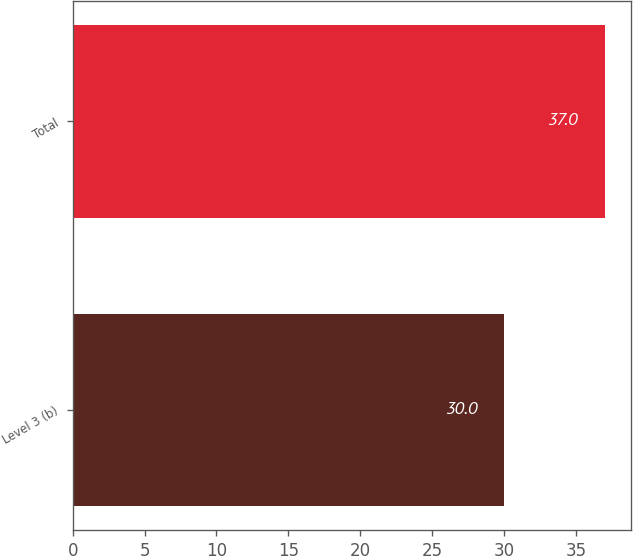<chart> <loc_0><loc_0><loc_500><loc_500><bar_chart><fcel>Level 3 (b)<fcel>Total<nl><fcel>30<fcel>37<nl></chart> 